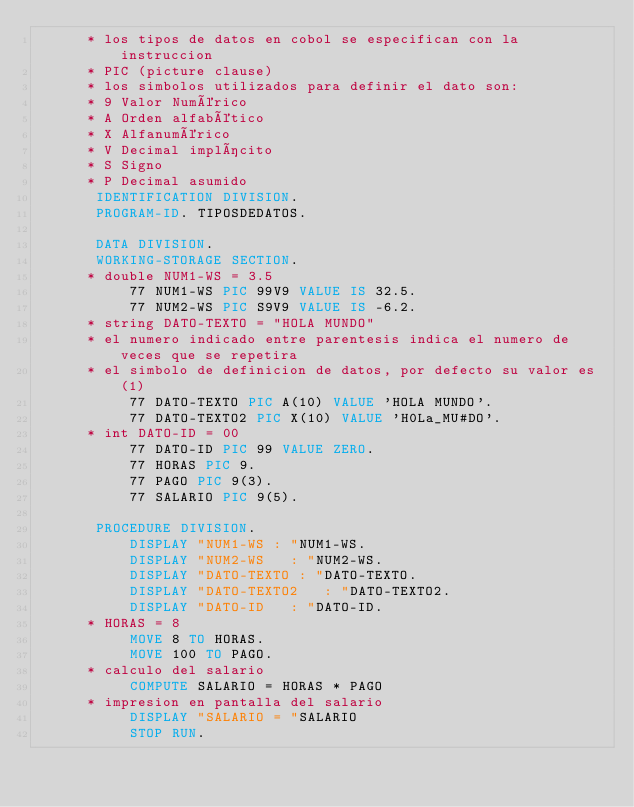<code> <loc_0><loc_0><loc_500><loc_500><_COBOL_>      * los tipos de datos en cobol se especifican con la instruccion
      * PIC (picture clause)
      * los simbolos utilizados para definir el dato son:
      * 9 Valor Numérico
      * A Orden alfabético
      * X Alfanumérico
      * V Decimal implícito
      * S Signo
      * P Decimal asumido
       IDENTIFICATION DIVISION.
       PROGRAM-ID. TIPOSDEDATOS.

       DATA DIVISION.
       WORKING-STORAGE SECTION.
      * double NUM1-WS = 3.5
           77 NUM1-WS PIC 99V9 VALUE IS 32.5.
           77 NUM2-WS PIC S9V9 VALUE IS -6.2.
      * string DATO-TEXTO = "HOLA MUNDO"
      * el numero indicado entre parentesis indica el numero de veces que se repetira
      * el simbolo de definicion de datos, por defecto su valor es (1)
           77 DATO-TEXTO PIC A(10) VALUE 'HOLA MUNDO'.
           77 DATO-TEXTO2 PIC X(10) VALUE 'H0La_MU#DO'.
      * int DATO-ID = 00
           77 DATO-ID PIC 99 VALUE ZERO.
           77 HORAS PIC 9.
           77 PAGO PIC 9(3).
           77 SALARIO PIC 9(5).

       PROCEDURE DIVISION.
           DISPLAY "NUM1-WS : "NUM1-WS.
           DISPLAY "NUM2-WS   : "NUM2-WS.
           DISPLAY "DATO-TEXTO : "DATO-TEXTO.
           DISPLAY "DATO-TEXTO2   : "DATO-TEXTO2.
           DISPLAY "DATO-ID   : "DATO-ID.
      * HORAS = 8
           MOVE 8 TO HORAS.
           MOVE 100 TO PAGO.
      * calculo del salario
           COMPUTE SALARIO = HORAS * PAGO
      * impresion en pantalla del salario
           DISPLAY "SALARIO = "SALARIO
           STOP RUN.
</code> 